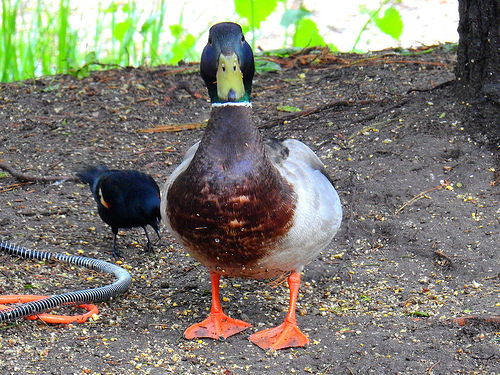<image>
Can you confirm if the duck is in the bird? No. The duck is not contained within the bird. These objects have a different spatial relationship. Is the duck in front of the bird? Yes. The duck is positioned in front of the bird, appearing closer to the camera viewpoint. 